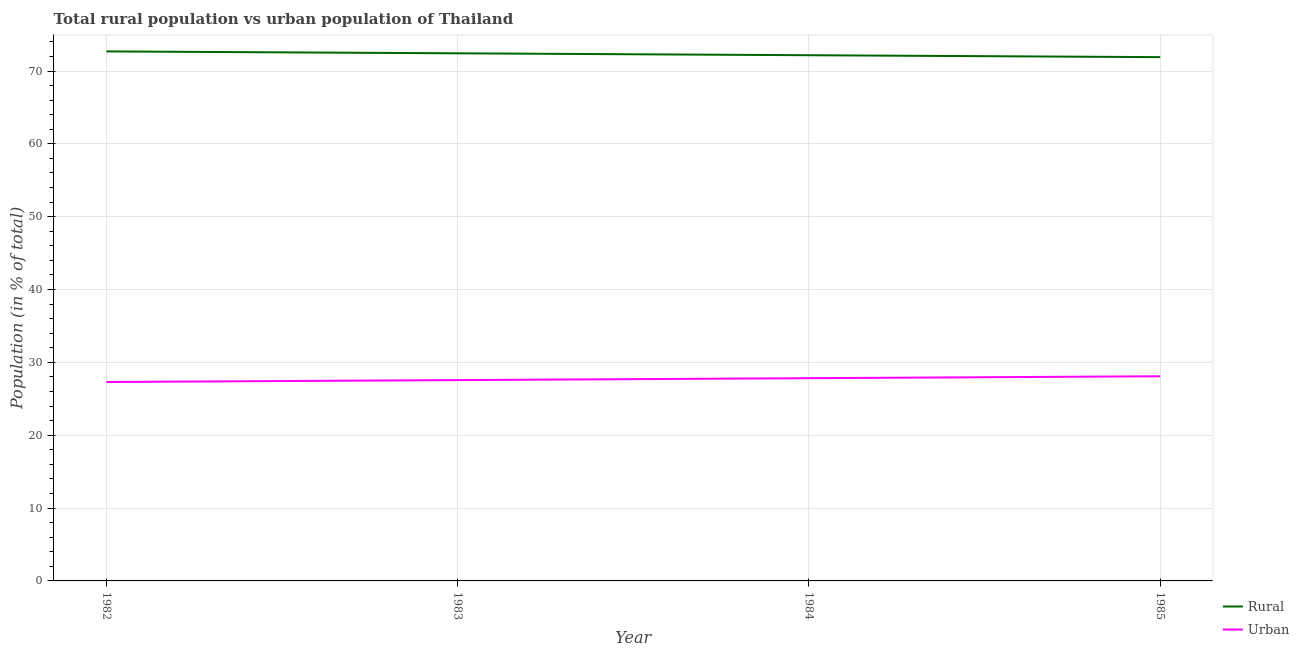Is the number of lines equal to the number of legend labels?
Offer a terse response. Yes. What is the urban population in 1984?
Keep it short and to the point. 27.83. Across all years, what is the maximum rural population?
Your answer should be very brief. 72.69. Across all years, what is the minimum rural population?
Keep it short and to the point. 71.91. In which year was the rural population maximum?
Keep it short and to the point. 1982. What is the total rural population in the graph?
Provide a short and direct response. 289.2. What is the difference between the rural population in 1982 and that in 1983?
Keep it short and to the point. 0.26. What is the difference between the rural population in 1985 and the urban population in 1982?
Provide a short and direct response. 44.6. What is the average rural population per year?
Ensure brevity in your answer.  72.3. In the year 1984, what is the difference between the urban population and rural population?
Your response must be concise. -44.34. What is the ratio of the rural population in 1983 to that in 1985?
Give a very brief answer. 1.01. Is the urban population in 1984 less than that in 1985?
Provide a succinct answer. Yes. Is the difference between the rural population in 1982 and 1984 greater than the difference between the urban population in 1982 and 1984?
Provide a short and direct response. Yes. What is the difference between the highest and the second highest urban population?
Keep it short and to the point. 0.26. What is the difference between the highest and the lowest rural population?
Give a very brief answer. 0.79. Is the sum of the rural population in 1982 and 1984 greater than the maximum urban population across all years?
Keep it short and to the point. Yes. Does the rural population monotonically increase over the years?
Ensure brevity in your answer.  No. What is the difference between two consecutive major ticks on the Y-axis?
Give a very brief answer. 10. Are the values on the major ticks of Y-axis written in scientific E-notation?
Offer a terse response. No. Does the graph contain any zero values?
Offer a very short reply. No. Where does the legend appear in the graph?
Offer a terse response. Bottom right. How many legend labels are there?
Your response must be concise. 2. What is the title of the graph?
Make the answer very short. Total rural population vs urban population of Thailand. What is the label or title of the Y-axis?
Ensure brevity in your answer.  Population (in % of total). What is the Population (in % of total) of Rural in 1982?
Provide a short and direct response. 72.69. What is the Population (in % of total) in Urban in 1982?
Your answer should be compact. 27.31. What is the Population (in % of total) in Rural in 1983?
Offer a terse response. 72.43. What is the Population (in % of total) in Urban in 1983?
Ensure brevity in your answer.  27.57. What is the Population (in % of total) of Rural in 1984?
Provide a short and direct response. 72.17. What is the Population (in % of total) of Urban in 1984?
Keep it short and to the point. 27.83. What is the Population (in % of total) of Rural in 1985?
Your response must be concise. 71.91. What is the Population (in % of total) in Urban in 1985?
Your response must be concise. 28.09. Across all years, what is the maximum Population (in % of total) of Rural?
Your answer should be compact. 72.69. Across all years, what is the maximum Population (in % of total) of Urban?
Give a very brief answer. 28.09. Across all years, what is the minimum Population (in % of total) in Rural?
Give a very brief answer. 71.91. Across all years, what is the minimum Population (in % of total) of Urban?
Offer a very short reply. 27.31. What is the total Population (in % of total) of Rural in the graph?
Ensure brevity in your answer.  289.2. What is the total Population (in % of total) in Urban in the graph?
Offer a very short reply. 110.8. What is the difference between the Population (in % of total) of Rural in 1982 and that in 1983?
Your response must be concise. 0.26. What is the difference between the Population (in % of total) of Urban in 1982 and that in 1983?
Ensure brevity in your answer.  -0.26. What is the difference between the Population (in % of total) of Rural in 1982 and that in 1984?
Your answer should be compact. 0.52. What is the difference between the Population (in % of total) of Urban in 1982 and that in 1984?
Provide a short and direct response. -0.52. What is the difference between the Population (in % of total) of Rural in 1982 and that in 1985?
Offer a very short reply. 0.79. What is the difference between the Population (in % of total) in Urban in 1982 and that in 1985?
Make the answer very short. -0.79. What is the difference between the Population (in % of total) of Rural in 1983 and that in 1984?
Your answer should be compact. 0.26. What is the difference between the Population (in % of total) of Urban in 1983 and that in 1984?
Keep it short and to the point. -0.26. What is the difference between the Population (in % of total) in Rural in 1983 and that in 1985?
Give a very brief answer. 0.53. What is the difference between the Population (in % of total) of Urban in 1983 and that in 1985?
Offer a very short reply. -0.53. What is the difference between the Population (in % of total) of Rural in 1984 and that in 1985?
Make the answer very short. 0.26. What is the difference between the Population (in % of total) of Urban in 1984 and that in 1985?
Give a very brief answer. -0.26. What is the difference between the Population (in % of total) of Rural in 1982 and the Population (in % of total) of Urban in 1983?
Offer a very short reply. 45.12. What is the difference between the Population (in % of total) of Rural in 1982 and the Population (in % of total) of Urban in 1984?
Your answer should be very brief. 44.86. What is the difference between the Population (in % of total) of Rural in 1982 and the Population (in % of total) of Urban in 1985?
Provide a succinct answer. 44.6. What is the difference between the Population (in % of total) of Rural in 1983 and the Population (in % of total) of Urban in 1984?
Your answer should be very brief. 44.6. What is the difference between the Population (in % of total) in Rural in 1983 and the Population (in % of total) in Urban in 1985?
Offer a very short reply. 44.34. What is the difference between the Population (in % of total) in Rural in 1984 and the Population (in % of total) in Urban in 1985?
Offer a very short reply. 44.07. What is the average Population (in % of total) in Rural per year?
Offer a terse response. 72.3. What is the average Population (in % of total) of Urban per year?
Your response must be concise. 27.7. In the year 1982, what is the difference between the Population (in % of total) in Rural and Population (in % of total) in Urban?
Keep it short and to the point. 45.38. In the year 1983, what is the difference between the Population (in % of total) in Rural and Population (in % of total) in Urban?
Your response must be concise. 44.86. In the year 1984, what is the difference between the Population (in % of total) in Rural and Population (in % of total) in Urban?
Ensure brevity in your answer.  44.34. In the year 1985, what is the difference between the Population (in % of total) of Rural and Population (in % of total) of Urban?
Ensure brevity in your answer.  43.81. What is the ratio of the Population (in % of total) in Rural in 1982 to that in 1983?
Keep it short and to the point. 1. What is the ratio of the Population (in % of total) of Urban in 1982 to that in 1983?
Give a very brief answer. 0.99. What is the ratio of the Population (in % of total) of Rural in 1982 to that in 1984?
Your answer should be compact. 1.01. What is the ratio of the Population (in % of total) of Urban in 1982 to that in 1984?
Provide a succinct answer. 0.98. What is the ratio of the Population (in % of total) in Rural in 1982 to that in 1985?
Give a very brief answer. 1.01. What is the ratio of the Population (in % of total) of Urban in 1983 to that in 1984?
Your answer should be compact. 0.99. What is the ratio of the Population (in % of total) of Rural in 1983 to that in 1985?
Offer a terse response. 1.01. What is the ratio of the Population (in % of total) of Urban in 1983 to that in 1985?
Your answer should be compact. 0.98. What is the ratio of the Population (in % of total) of Rural in 1984 to that in 1985?
Provide a short and direct response. 1. What is the ratio of the Population (in % of total) in Urban in 1984 to that in 1985?
Your answer should be compact. 0.99. What is the difference between the highest and the second highest Population (in % of total) of Rural?
Your answer should be very brief. 0.26. What is the difference between the highest and the second highest Population (in % of total) in Urban?
Provide a succinct answer. 0.26. What is the difference between the highest and the lowest Population (in % of total) of Rural?
Your response must be concise. 0.79. What is the difference between the highest and the lowest Population (in % of total) in Urban?
Keep it short and to the point. 0.79. 